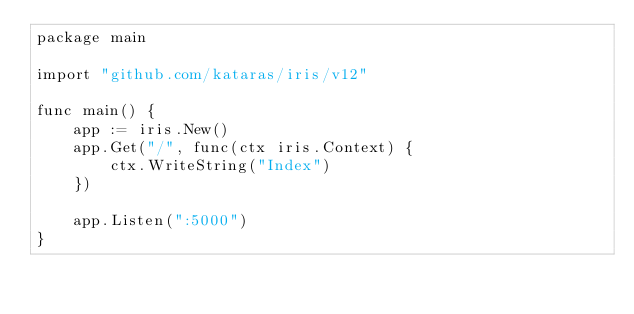Convert code to text. <code><loc_0><loc_0><loc_500><loc_500><_Go_>package main

import "github.com/kataras/iris/v12"

func main() {
	app := iris.New()
	app.Get("/", func(ctx iris.Context) {
		ctx.WriteString("Index")
	})

	app.Listen(":5000")
}
</code> 